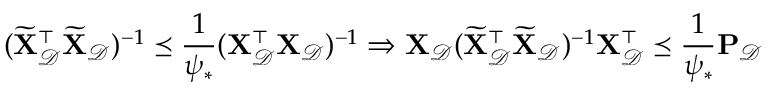<formula> <loc_0><loc_0><loc_500><loc_500>( \widetilde { X } _ { \mathcal { D } } ^ { \top } \widetilde { X } _ { \mathcal { D } } ) ^ { - 1 } \preceq \frac { 1 } { \psi _ { * } } ( X _ { \mathcal { D } } ^ { \top } X _ { \mathcal { D } } ) ^ { - 1 } \Rightarrow X _ { \mathcal { D } } ( \widetilde { X } _ { \mathcal { D } } ^ { \top } \widetilde { X } _ { \mathcal { D } } ) ^ { - 1 } X _ { \mathcal { D } } ^ { \top } \preceq \frac { 1 } { \psi _ { * } } P _ { \mathcal { D } }</formula> 